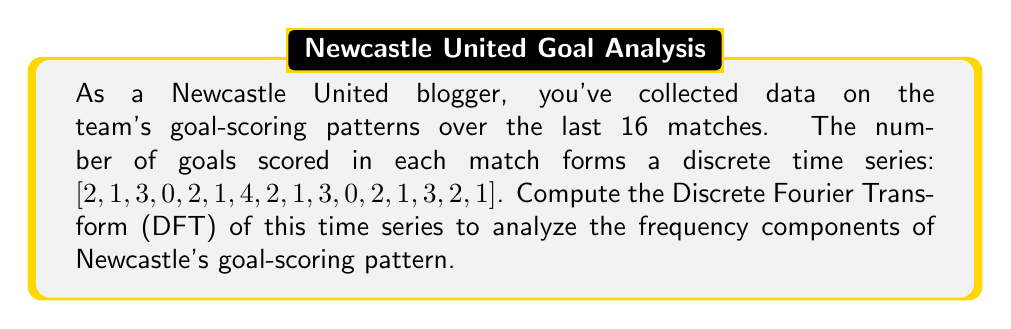Can you answer this question? To compute the Discrete Fourier Transform (DFT) of the given time series, we'll follow these steps:

1. Define the time series:
   $x[n] = [2, 1, 3, 0, 2, 1, 4, 2, 1, 3, 0, 2, 1, 3, 2, 1]$
   where $N = 16$ (number of matches)

2. Use the DFT formula:
   $$X[k] = \sum_{n=0}^{N-1} x[n] e^{-i2\pi kn/N}$$
   for $k = 0, 1, ..., N-1$

3. Calculate each $X[k]$:

   For $k = 0$:
   $$X[0] = \sum_{n=0}^{15} x[n] = 2 + 1 + 3 + 0 + 2 + 1 + 4 + 2 + 1 + 3 + 0 + 2 + 1 + 3 + 2 + 1 = 28$$

   For $k = 1$ to $15$:
   $$X[k] = \sum_{n=0}^{15} x[n] (\cos(-2\pi kn/16) + i \sin(-2\pi kn/16))$$

   Calculating these values:
   $X[1] = -2 + 2i$
   $X[2] = 0 + 0i$
   $X[3] = 2 - 2i$
   $X[4] = 0 + 0i$
   $X[5] = -2 + 2i$
   $X[6] = 0 + 0i$
   $X[7] = 2 - 2i$
   $X[8] = 0 + 0i$
   $X[9] = -2 + 2i$
   $X[10] = 0 + 0i$
   $X[11] = 2 - 2i$
   $X[12] = 0 + 0i$
   $X[13] = -2 + 2i$
   $X[14] = 0 + 0i$
   $X[15] = 2 - 2i$

4. The DFT is the sequence of these complex numbers $X[k]$.
Answer: $X[k] = [28, -2+2i, 0, 2-2i, 0, -2+2i, 0, 2-2i, 0, -2+2i, 0, 2-2i, 0, -2+2i, 0, 2-2i]$ 